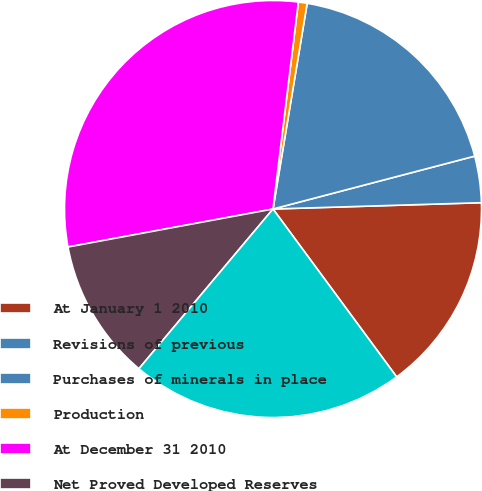Convert chart to OTSL. <chart><loc_0><loc_0><loc_500><loc_500><pie_chart><fcel>At January 1 2010<fcel>Revisions of previous<fcel>Purchases of minerals in place<fcel>Production<fcel>At December 31 2010<fcel>Net Proved Developed Reserves<fcel>Net Proved Undeveloped<nl><fcel>15.38%<fcel>3.6%<fcel>18.3%<fcel>0.68%<fcel>29.86%<fcel>10.97%<fcel>21.22%<nl></chart> 